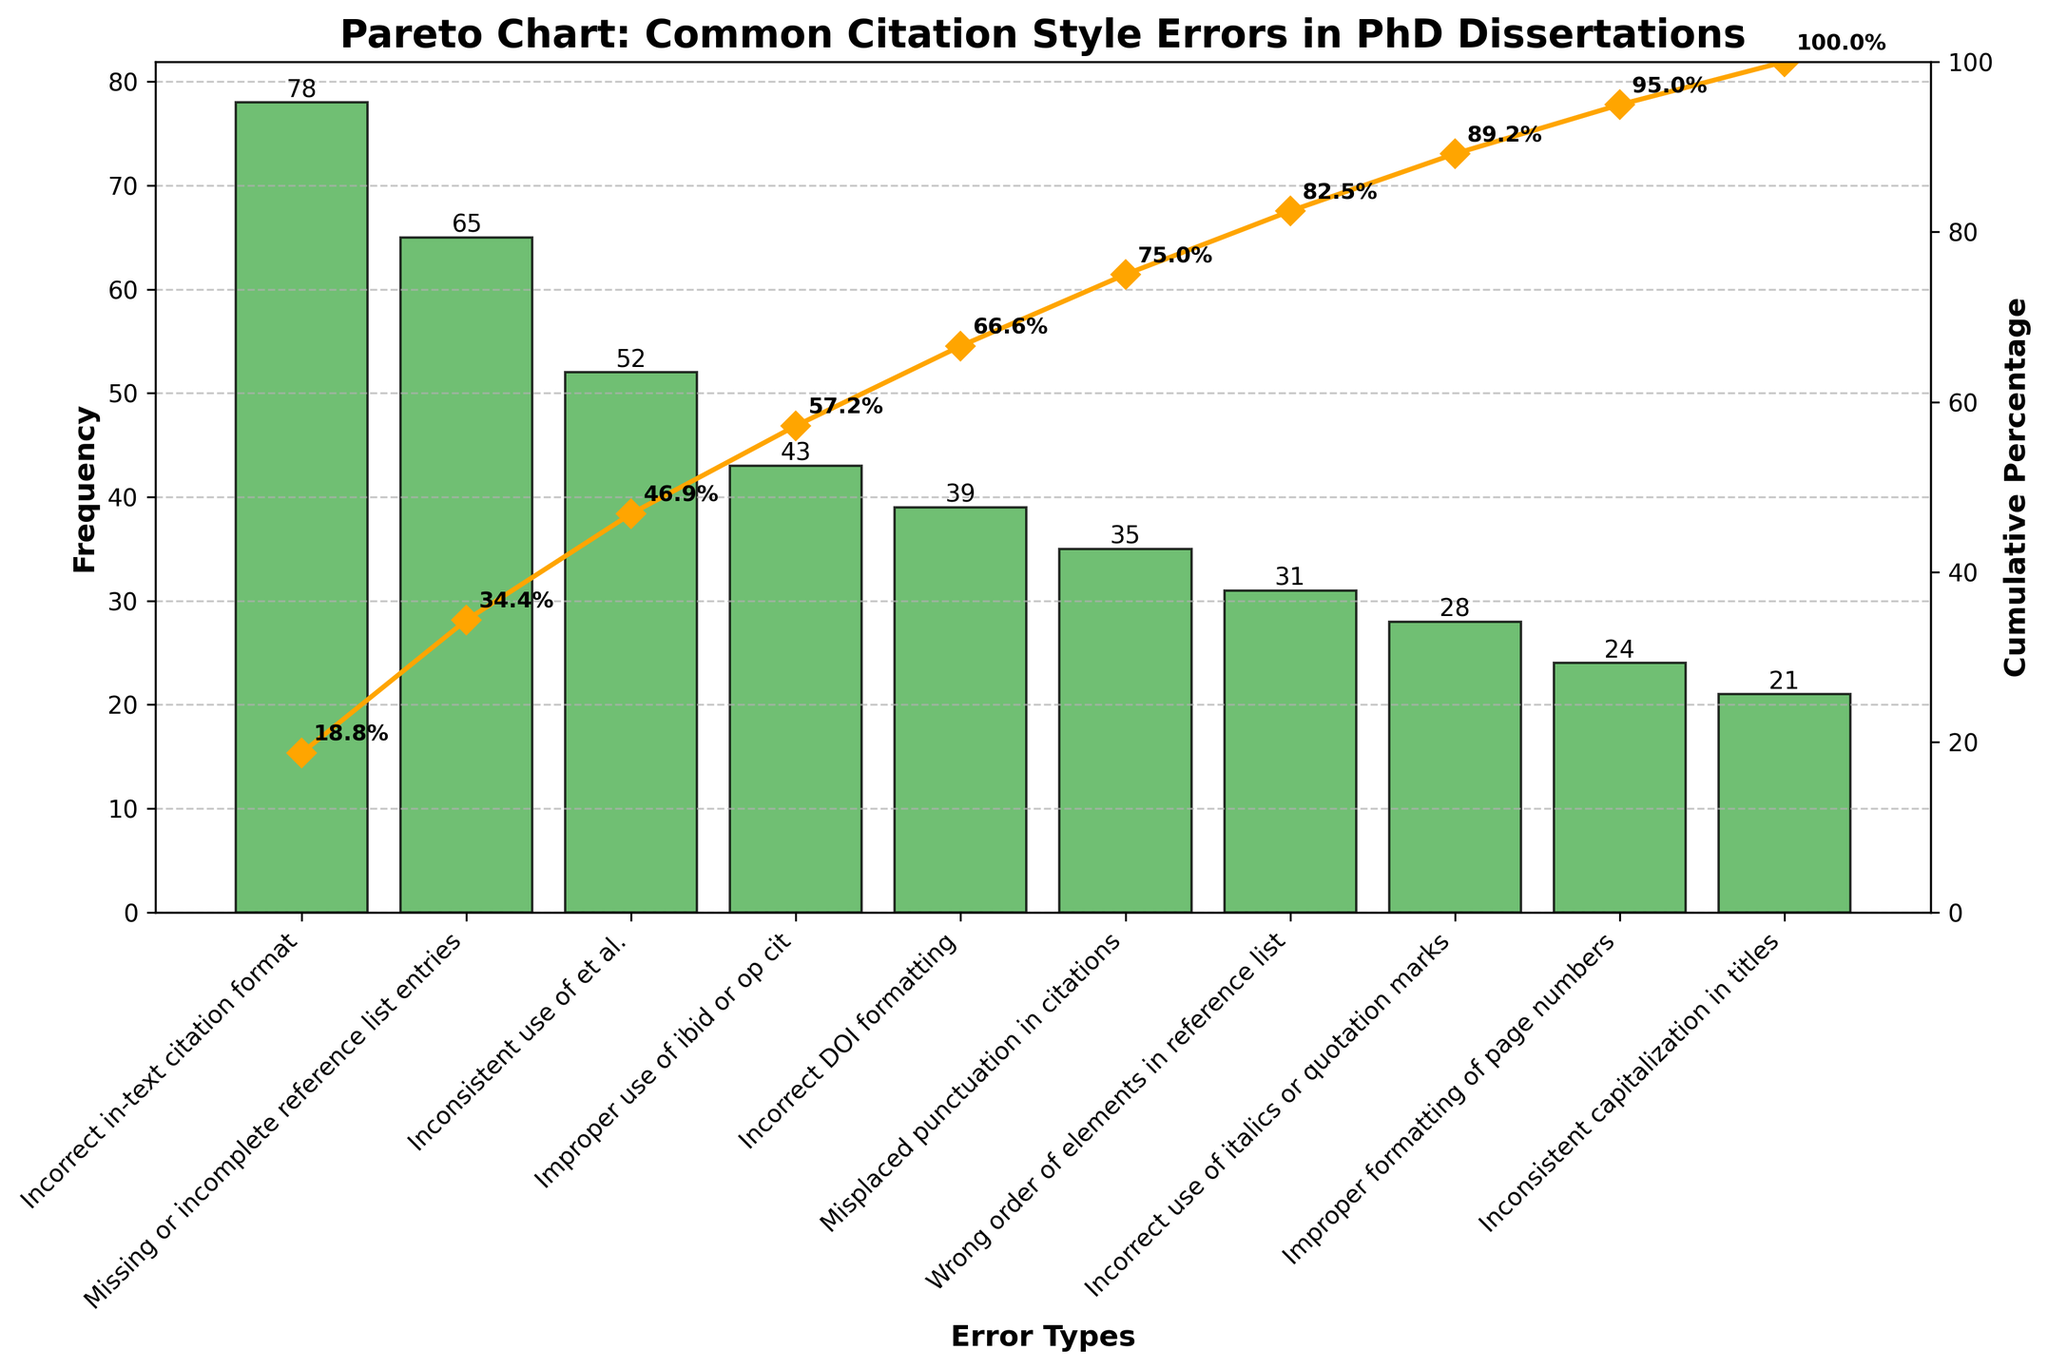Which error type has the highest frequency? The figure shows the frequencies of different citation style errors, and "Incorrect in-text citation format" is the tallest bar, indicating it has the highest frequency.
Answer: Incorrect in-text citation format What is the cumulative percentage of the two most frequent error types? The cumulative percentage line is at 36.2% after the first error (Incorrect in-text citation format), and it reaches 66.4% after the second error (Missing or incomplete reference list entries). Therefore, adding these two gives us 66.4%.
Answer: 66.4% How many types of citation style errors have a frequency lower than 30? By looking at the bar chart, we can see that the errors with frequencies lower than 30 are "Incorrect use of italics or quotation marks" (28), "Improper formatting of page numbers" (24), and "Inconsistent capitalization in titles" (21). There are three such errors.
Answer: 3 Which error types have a frequency greater than 50 but less than 80? The bar chart shows that "Incorrect in-text citation format" has a frequency of 78, and "Missing or incomplete reference list entries" has a frequency of 65. Both frequencies fit the given range.
Answer: Incorrect in-text citation format, Missing or incomplete reference list entries What is the cumulative percentage after the first four error types? The cumulative percentage line shows the following values: 36.2% after the first error, 66.4% after the second, 90.2% after the third, and 108% after the fourth. However, since percentages cannot exceed 100%, the cumulative percentage after the fourth should be capped at 100%.
Answer: 100% What is the frequency difference between "Inconsistent use of et al." and "Improper use of ibid or op cit"? The bar chart shows that the frequency of "Inconsistent use of et al." is 52, and "Improper use of ibid or op cit" is 43. The difference is 52 - 43 = 9.
Answer: 9 What percentage of the total errors are attributed to "Incorrect DOI formatting"? The total number of errors is the sum of all frequencies, which is 406. The frequency of "Incorrect DOI formatting" is 39. The percentage is (39/406) * 100 ≈ 9.6%.
Answer: 9.6% Which is the first error type to push the cumulative percentage over 50%? The bar chart and the cumulative percentage line show that the second error type, "Missing or incomplete reference list entries," pushes the cumulative percentage from 36.2% to 66.4%, exceeding 50%.
Answer: Missing or incomplete reference list entries Are more than half of the errors accounted for by the first three error types? The cumulative percentage line indicates that the first three errors account for 90.2% of the total errors, which is more than half.
Answer: Yes What is the cumulative percentage after "Incorrect DOI formatting"? The cumulative percentage line shows that after "Incorrect DOI formatting," the cumulative percentage is 96.3%.
Answer: 96.3% 